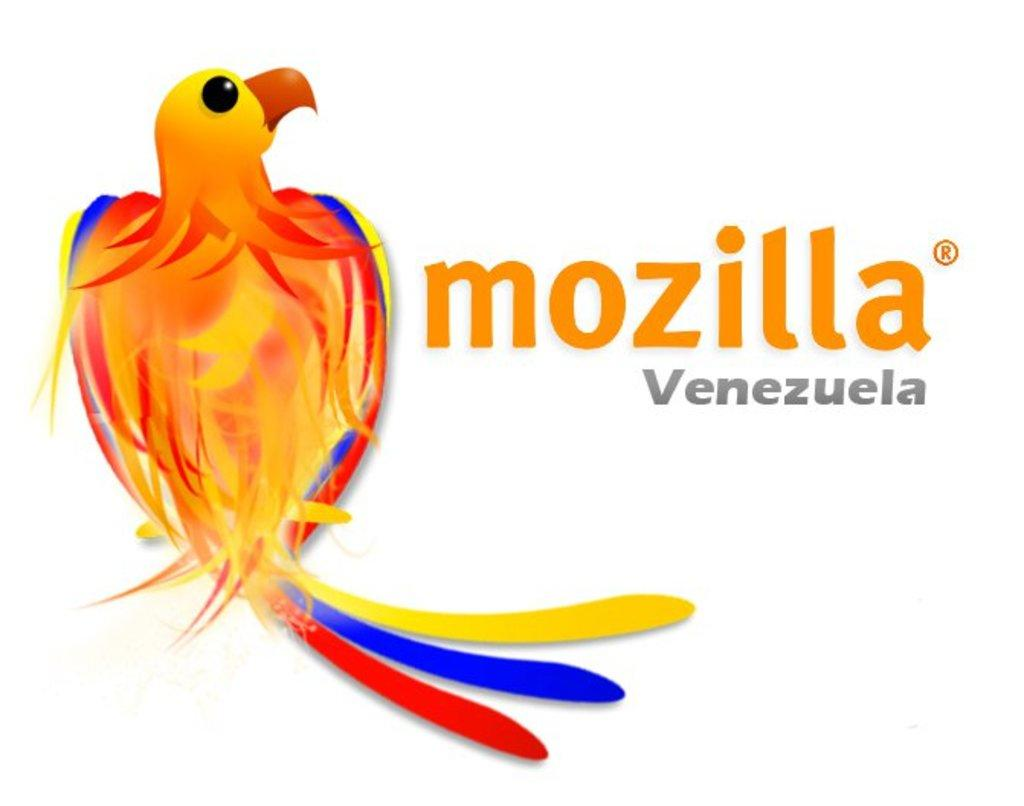What is the main feature of the image? There is a logo in the image. What is depicted in the logo? The logo contains a bird. Are there any words or letters in the logo? Yes, there is text present in the logo. How many times does the bird cry in the image? There is no bird crying in the image, as it is a static logo. What part of the brain is depicted in the image? There is no depiction of a brain in the image; it features a bird and text in a logo. 